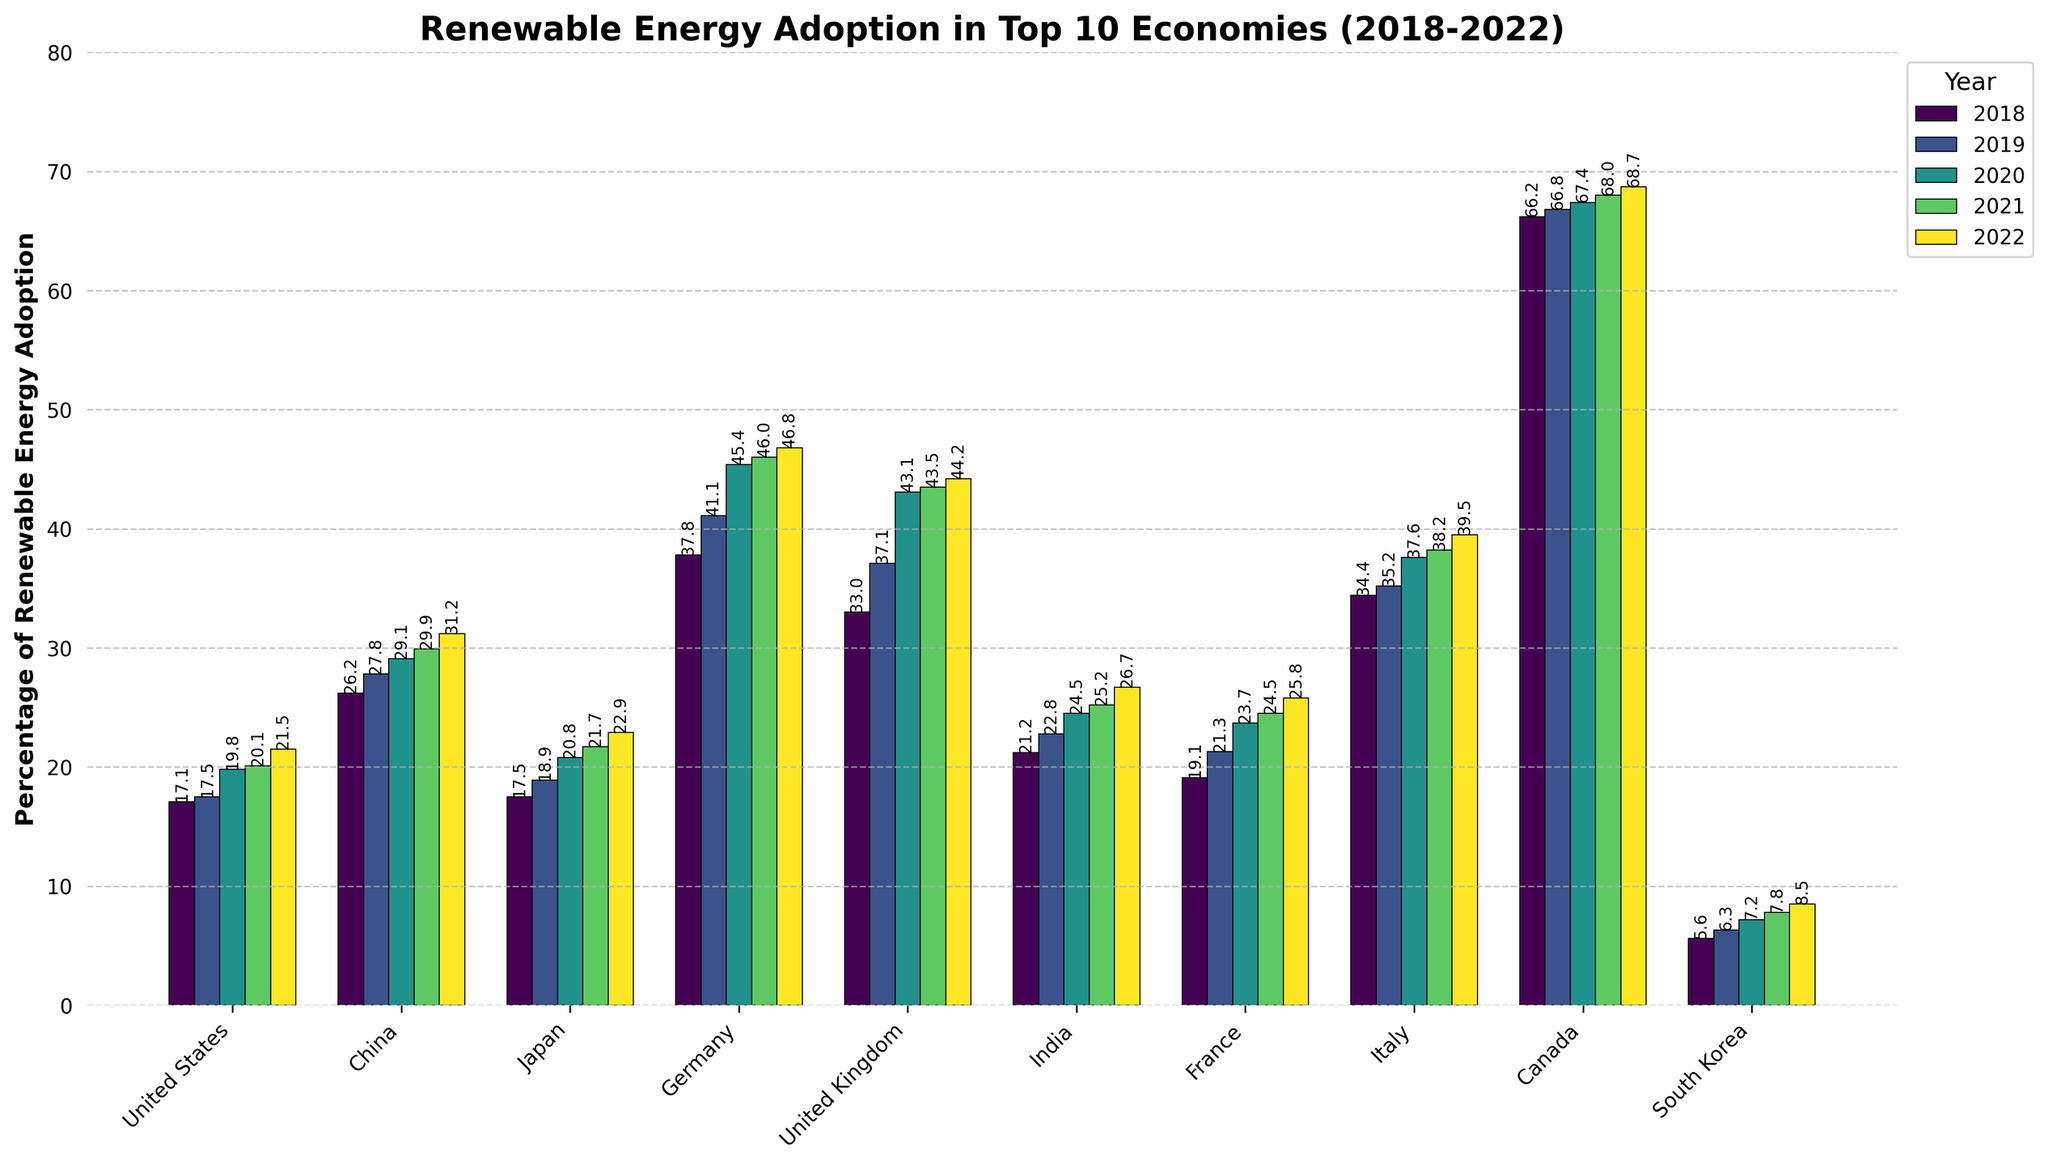What is the percentage of renewable energy adoption in Canada in 2020? Look at the bar label corresponding to Canada and the year 2020.
Answer: 67.4 Which country saw the greatest increase in renewable energy adoption between 2018 and 2022? Calculate the difference between the 2022 and 2018 percentages for each country and compare them. Canada increased from 66.2% to 68.7% (2.5%), China from 26.2% to 31.2% (5%), Germany from 37.8% to 46.8% (9%), and so on.
Answer: Germany (9.0%) How does the renewable energy adoption in the United States in 2022 compare to China in the same year? Compare the height of the bars for the United States and China in 2022. According to the figure, the percentage for the United States in 2022 is 21.5% and for China, it is 31.2%.
Answer: China has a higher percentage What is the average percentage of renewable energy adoption across all countries in 2019? Sum the percentages of all countries in 2019 and divide by the number of countries. (17.5 + 27.8 + 18.9 + 41.1 + 37.1 + 22.8 + 21.3 + 35.2 + 66.8 + 6.3) / 10 = 29.48%
Answer: 29.48% Which country has the smallest percentage of renewable energy adoption in 2022? Check the lowest bar height in the 2022 column. According to the figure, South Korea has the lowest percentage in 2022, which is 8.5%.
Answer: South Korea Between 2018 and 2019, which country had the highest increase in percentage points? Calculate the differences between 2018 and 2019 for each country, and find the maximum. For example, for Germany: 41.1 - 37.8 = 3.3, for the UK: 37.1 - 33.0 = 4.1, etc.
Answer: United Kingdom (4.1) What is the trend in renewable energy adoption for Japan from 2018 to 2022? Analyze the heights of the bars for Japan over the years 2018 to 2022, which show a steady increase: 17.5, 18.9, 20.8, 21.7, 22.9.
Answer: Increasing What is the median percentage of renewable energy adoption in 2020 among the top 10 economies? Rank the countries by their 2020 percentages: (5.6, 17.5, 19.8, 20.8, 23.7, 24.5, 29.1, 37.6, 43.1, 67.4). The median is the sixth value in this sorted list: 24.5.
Answer: 24.5% Which two countries had nearly identical increases in renewable energy adoption between 2019 and 2020? Calculate and compare the increases for each country between 2019 and 2020. For instance, China: 29.1 - 27.8 = 1.3, India: 24.5 - 22.8 = 1.7. Through comparison, Japan (1.9) and the United States (2.3) had similar increases.
Answer: Japan and United States Which country had the largest percentage of renewable energy in any year over the period covered by the figure? Check the vertical heights of the bars across all years and identify the largest value. The highest percentage is from Canada in all years, peaking at 68.7% in 2022.
Answer: Canada 